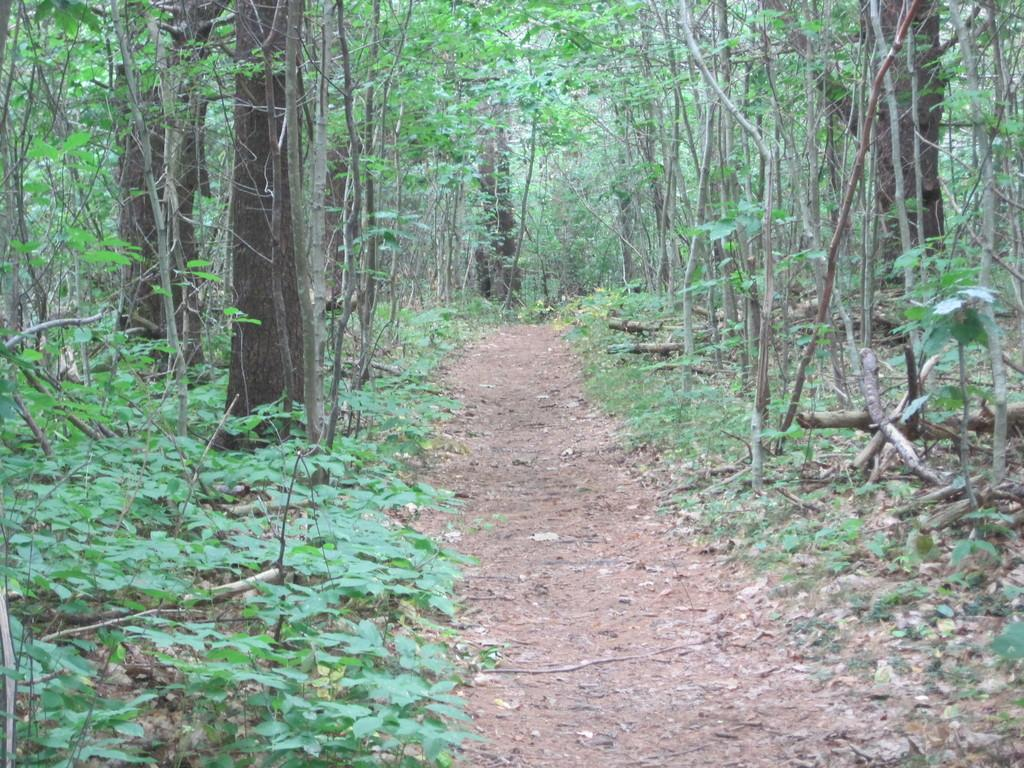What is the main feature of the image? The main feature of the image is a path. Where is the path located in relation to the surrounding environment? The path is situated between trees and plants. What type of prose is being written by the woman sitting on the path? There is no woman present in the image, and therefore no prose is being written. 